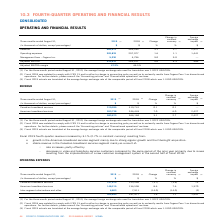According to Cogeco's financial document, What was the exchange rate in 2019? According to the financial document, 1.3222 USD/CDN.. The relevant text states: "age foreign exchange rate used for translation was 1.3222 USD/CDN...." Also, What was the exchange rate in 2018? According to the financial document, 1.3100 USD/CDN.. The relevant text states: "of the comparable period of fiscal 2018 which was 1.3100 USD/CDN...." Also, What was the increase in revenue in fourth-quarter 2019? According to the financial document, 3.1%. The relevant text states: "Fiscal 2019 fourth-quarter revenue increased by 3.1% (2.7% in constant currency) resulting from:..." Also, can you calculate: What is the increase / (decrease) in the Canadian broadband services from 2018 to 2019? Based on the calculation: 319,935 - 319,741, the result is 194 (in thousands). This is based on the information: "Canadian broadband services 319,935 319,741 0.1 0.1 — Canadian broadband services 319,935 319,741 0.1 0.1 —..." The key data points involved are: 319,741, 319,935. Also, can you calculate: What was the average Canadian broadband services from 2018 to 2019? To answer this question, I need to perform calculations using the financial data. The calculation is: (319,935 + 319,741) / 2, which equals 319838 (in thousands). This is based on the information: "Canadian broadband services 319,935 319,741 0.1 0.1 — Canadian broadband services 319,935 319,741 0.1 0.1 —..." The key data points involved are: 319,741, 319,935. Also, can you calculate: What was the average American broadband services from 2018 to 2019? To answer this question, I need to perform calculations using the financial data. The calculation is: (263,738 + 246,443) / 2, which equals 255090.5 (in thousands). This is based on the information: "American broadband services 263,738 246,443 7.0 6.0 2,427 American broadband services 263,738 246,443 7.0 6.0 2,427..." The key data points involved are: 246,443, 263,738. 